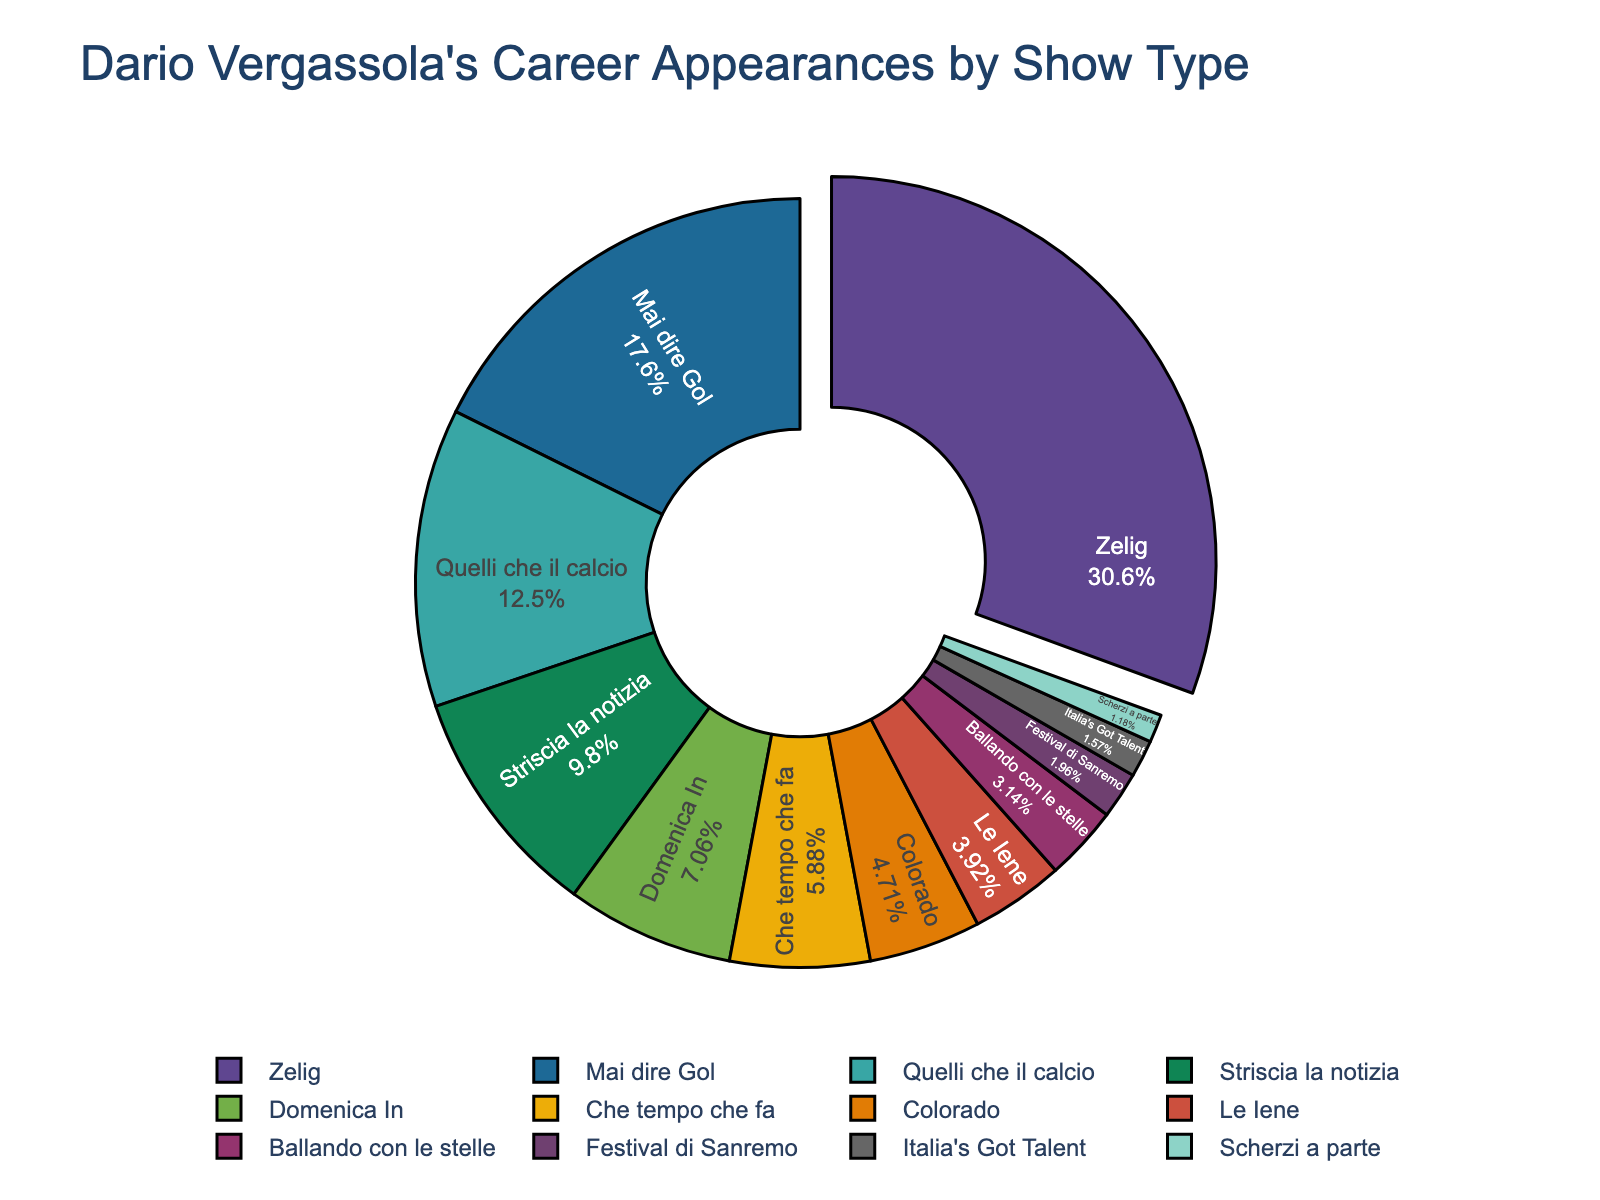What percentage of Dario Vergassola's career appearances were on Zelig? The pie chart shows that Zelig has the largest segment. To find the percentage, we look at the label inside the Zelig section.
Answer: Zelig: 34.8% Which show has the second highest number of appearances? After visually identifying the largest segment (Zelig), the next largest segment needs to be identified. Mai dire Gol appears as the second largest segment.
Answer: Mai dire Gol What's the difference in the number of appearances between Mai dire Gol and Che tempo che fa? Mai dire Gol has 45 appearances, and Che tempo che fa has 15 appearances. The difference is calculated as 45 - 15.
Answer: 30 How many shows have appearances in single digits? From the pie chart, identify the segments where the label shows a single-digit number: Ballando con le stelle, Italia's Got Talent, and Scherzi a parte.
Answer: 3 What is the combined percentage of appearances for Quelli che il calcio and Striscia la notizia? Identify the percentages for both shows (Quelli che il calcio: 14.3%, Striscia la notizia: 11.2%) and add them together: 14.3% + 11.2%.
Answer: 25.5% Which show has the smallest number of appearances, and what is that number? Identify the smallest segment in the pie chart which is Scherzi a parte, with 3 appearances.
Answer: Scherzi a parte: 3 Compare the segments by visual area: Does Quelli che il calcio have a larger visual area than Italia's Got Talent? By examining the size of the segments, Quelli che il calcio appears larger than Italia's Got Talent.
Answer: Yes Is the segment for Colorado larger than the segment for Le Iene? By comparing the segments visually, Colorado appears slightly larger than Le Iene.
Answer: Yes What's the average number of appearances for the shows that have more than 20 appearances? The shows and their appearances are Zelig (78), Mai dire Gol (45), Quelli che il calcio (32), and Striscia la notizia (25). The sum is 78 + 45 + 32 + 25 = 180. There are 4 shows, so the average is 180 / 4.
Answer: 45 Which show segments are visually pulled out from the rest of the pie chart? Notice the segment that is separated slightly from the pie. The Zelig segment is pulled out.
Answer: Zelig 